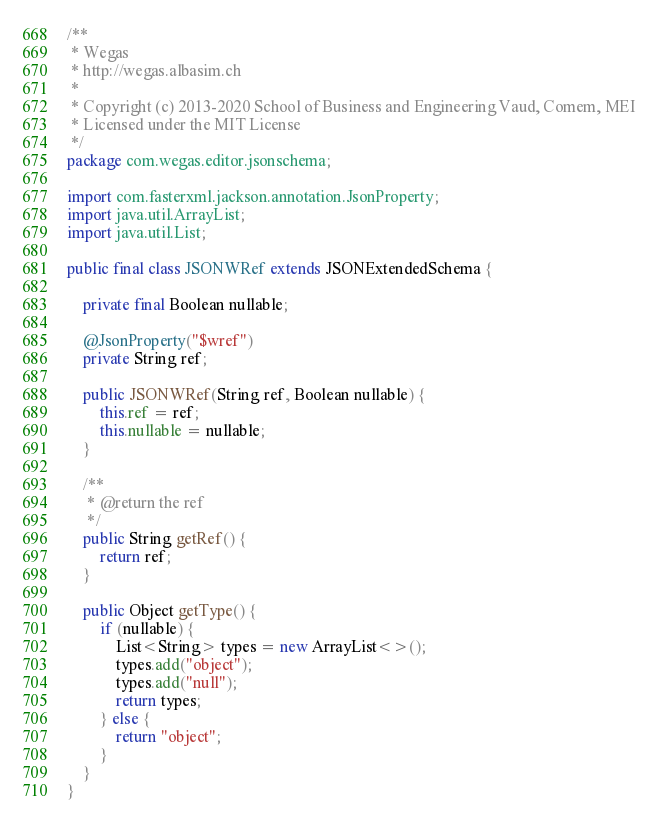Convert code to text. <code><loc_0><loc_0><loc_500><loc_500><_Java_>/**
 * Wegas
 * http://wegas.albasim.ch
 *
 * Copyright (c) 2013-2020 School of Business and Engineering Vaud, Comem, MEI
 * Licensed under the MIT License
 */
package com.wegas.editor.jsonschema;

import com.fasterxml.jackson.annotation.JsonProperty;
import java.util.ArrayList;
import java.util.List;

public final class JSONWRef extends JSONExtendedSchema {

    private final Boolean nullable;

    @JsonProperty("$wref")
    private String ref;

    public JSONWRef(String ref, Boolean nullable) {
        this.ref = ref;
        this.nullable = nullable;
    }

    /**
     * @return the ref
     */
    public String getRef() {
        return ref;
    }

    public Object getType() {
        if (nullable) {
            List<String> types = new ArrayList<>();
            types.add("object");
            types.add("null");
            return types;
        } else {
            return "object";
        }
    }
}
</code> 